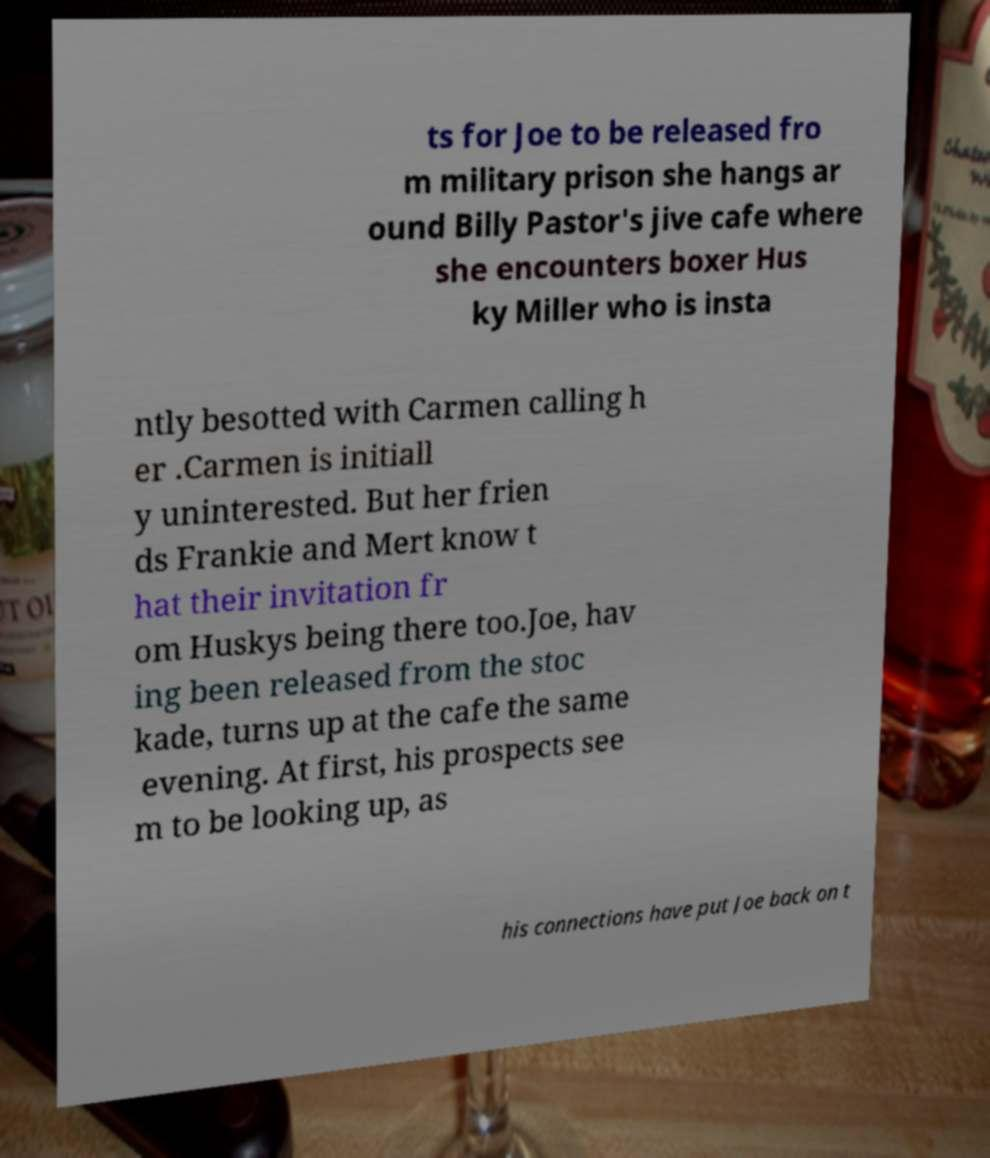Can you accurately transcribe the text from the provided image for me? ts for Joe to be released fro m military prison she hangs ar ound Billy Pastor's jive cafe where she encounters boxer Hus ky Miller who is insta ntly besotted with Carmen calling h er .Carmen is initiall y uninterested. But her frien ds Frankie and Mert know t hat their invitation fr om Huskys being there too.Joe, hav ing been released from the stoc kade, turns up at the cafe the same evening. At first, his prospects see m to be looking up, as his connections have put Joe back on t 